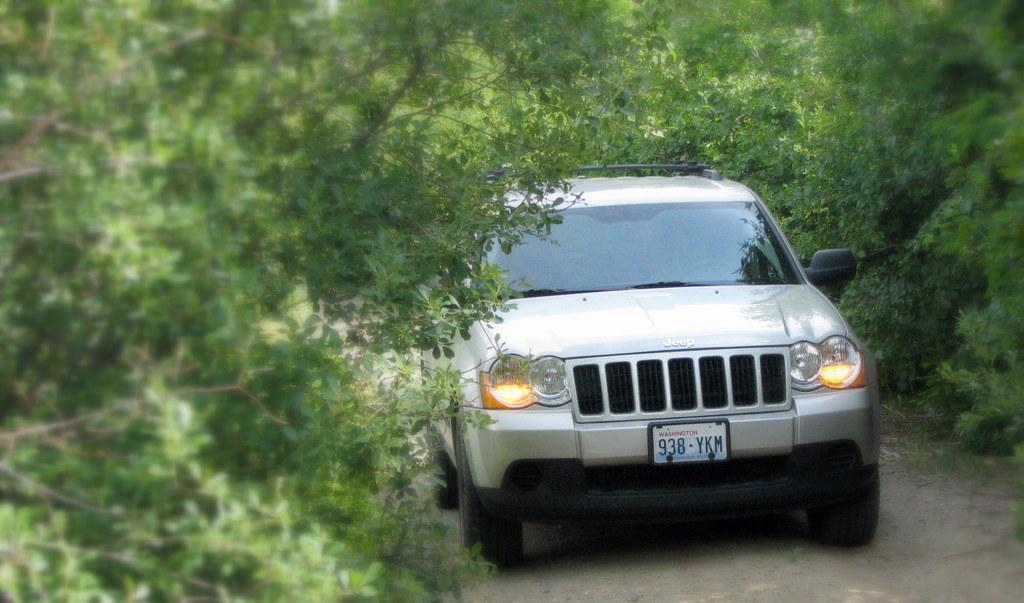What is the main subject of the image? There is a car in the image. Where is the car located? The car is on a road. What can be seen on both sides of the car? There are trees on either side of the car. What type of hair can be seen on the car's tires in the image? There is no hair present on the car's tires in the image. What instrument is the car playing in the background of the image? There is no drum or any musical instrument present in the image. 